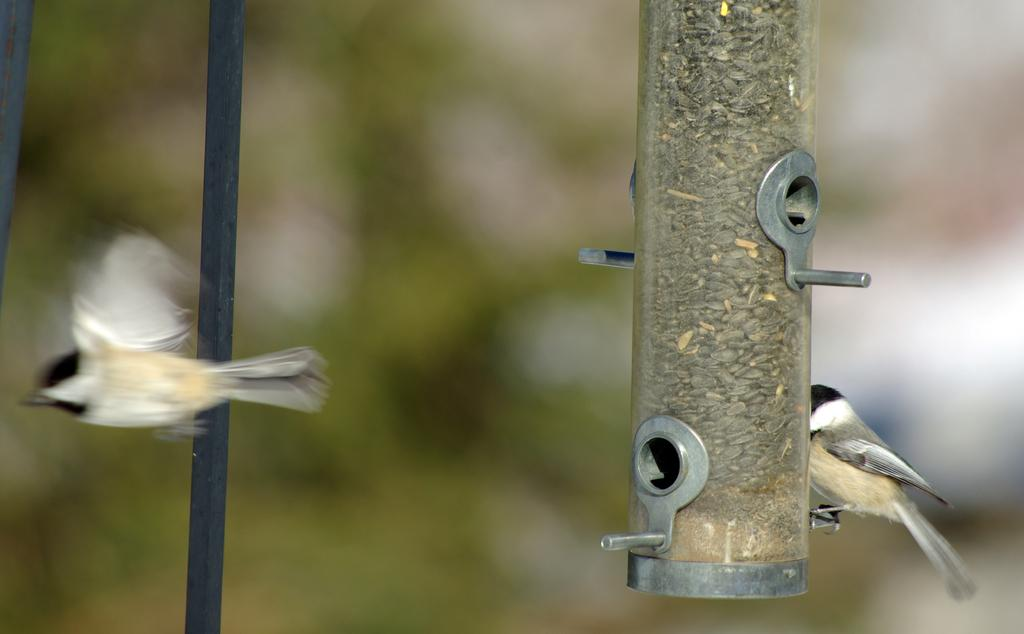What is the bird on the right side of the image doing? There is a bird on a bird feeder on the right side of the image. What is the bird on the left side of the image doing? There is a bird flying in the air on the left side of the image. What objects can be seen in the image besides the birds? There are rods in the image. How would you describe the background of the image? The background of the image is blurry. Can you see the bird's hand in the image? There are no hands visible in the image, as birds do not have hands. 